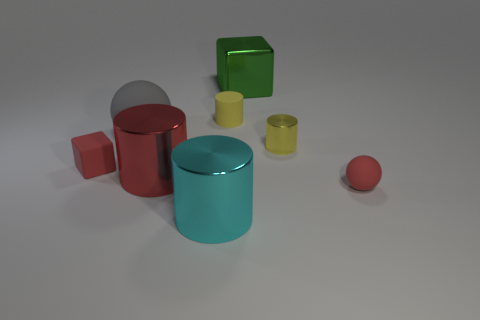What size is the shiny cylinder that is the same color as the tiny block?
Offer a terse response. Large. How many other things are there of the same color as the tiny metallic object?
Offer a terse response. 1. Is the number of metallic objects that are on the right side of the small yellow matte cylinder greater than the number of tiny yellow metal cylinders?
Your answer should be compact. Yes. There is a matte ball that is on the left side of the matte ball that is right of the cyan shiny object in front of the red rubber cube; what is its color?
Your answer should be very brief. Gray. Does the large red thing have the same material as the gray thing?
Offer a very short reply. No. Are there any brown cylinders that have the same size as the yellow rubber thing?
Offer a very short reply. No. There is a gray sphere that is the same size as the red metal cylinder; what material is it?
Give a very brief answer. Rubber. Is there another big metallic thing of the same shape as the cyan object?
Offer a very short reply. Yes. What material is the ball that is the same color as the small block?
Keep it short and to the point. Rubber. There is a large red thing that is in front of the big shiny block; what is its shape?
Your response must be concise. Cylinder. 